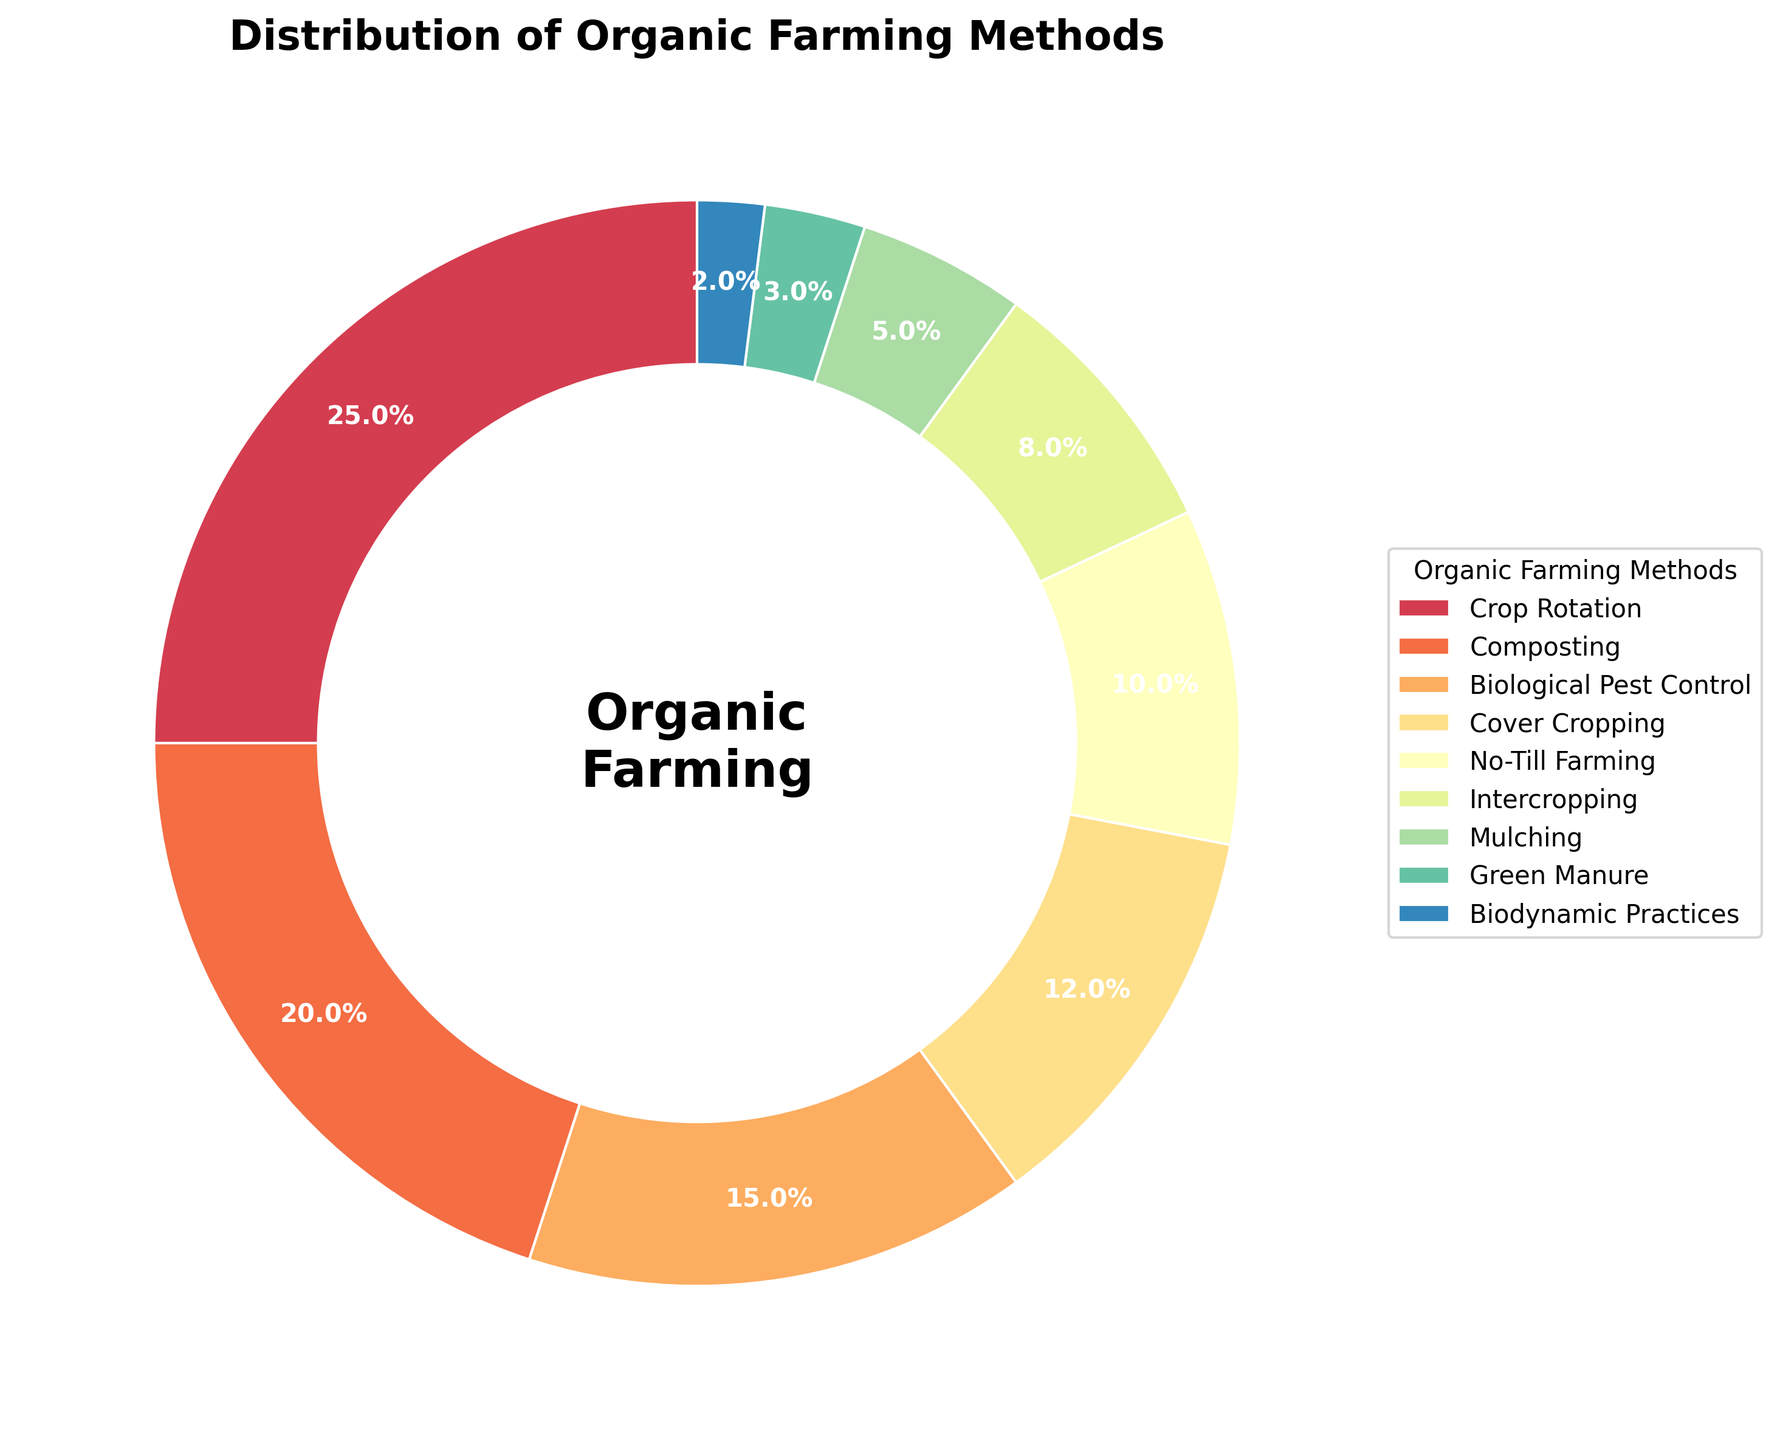What percentage of the methods used belong to 'Biological Pest Control' or 'Cover Cropping'? The percentage for 'Biological Pest Control' is 15% and for 'Cover Cropping' is 12%. Summing these two percentages: 15% + 12% = 27%.
Answer: 27% Which method has the smallest share of usage in the experiment? Looking at the percentages, 'Biodynamic Practices' has the smallest share with 2%.
Answer: Biodynamic Practices What is the combined percentage for 'Composting', 'Intercropping', and 'Green Manure'? The percentages for these methods are 'Composting' = 20%, 'Intercropping' = 8%, and 'Green Manure' = 3%. Adding these together: 20% + 8% + 3% = 31%.
Answer: 31% Is the percentage of 'No-Till Farming' greater than 'Mulching'? 'No-Till Farming' has 10% usage, while 'Mulching' has 5%. Therefore, 10% is greater than 5%.
Answer: Yes How does the percentage of 'Crop Rotation' compare to the sum of 'Biodynamic Practices' and 'Green Manure'? 'Crop Rotation' has 25%, while the combined percentage of 'Biodynamic Practices' and 'Green Manure' is 2% + 3% = 5%. 25% is greater than 5%.
Answer: Greater If 'Biological Pest Control' and 'Intercropping' were combined into a single method, what would their total percentage be? The percentages are 'Biological Pest Control' = 15% and 'Intercropping' = 8%. Summing them up: 15% + 8% = 23%.
Answer: 23% Which methods have a percentage less than 10%? From the data: 'Intercropping' = 8%, 'Mulching' = 5%, 'Green Manure' = 3%, 'Biodynamic Practices' = 2%.
Answer: Intercropping, Mulching, Green Manure, Biodynamic Practices Is 'Composting' one of the top three methods used in the experiment? The top three methods are: 'Crop Rotation' = 25%, 'Composting' = 20%, and 'Biological Pest Control' = 15%. Therefore, 'Composting' is one of the top three.
Answer: Yes What is the difference in usage percentage between 'Cover Cropping' and 'No-Till Farming'? 'Cover Cropping' has 12% and 'No-Till Farming' has 10%. The difference is 12% - 10% = 2%.
Answer: 2% List all methods that account for more than 15% of the usage. The only methods with more than 15% are: 'Crop Rotation' = 25% and 'Composting' = 20%.
Answer: Crop Rotation, Composting 